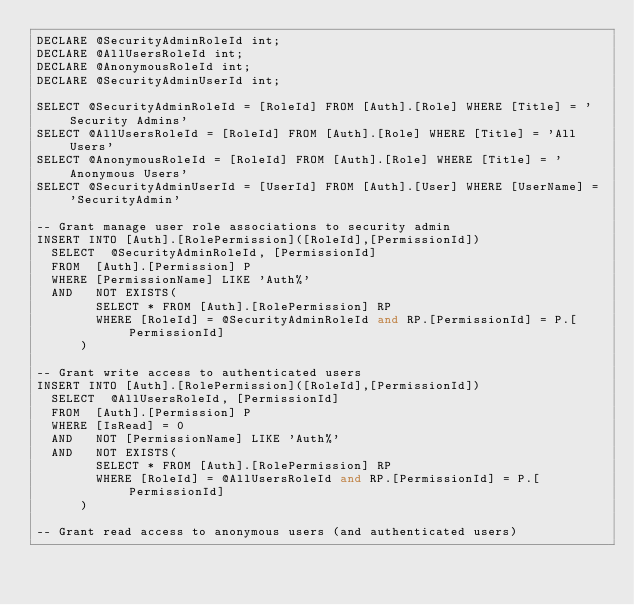Convert code to text. <code><loc_0><loc_0><loc_500><loc_500><_SQL_>DECLARE @SecurityAdminRoleId int;
DECLARE @AllUsersRoleId int;
DECLARE @AnonymousRoleId int;
DECLARE @SecurityAdminUserId int;

SELECT @SecurityAdminRoleId = [RoleId] FROM [Auth].[Role] WHERE [Title] = 'Security Admins'
SELECT @AllUsersRoleId = [RoleId] FROM [Auth].[Role] WHERE [Title] = 'All Users'
SELECT @AnonymousRoleId = [RoleId] FROM [Auth].[Role] WHERE [Title] = 'Anonymous Users'
SELECT @SecurityAdminUserId = [UserId] FROM [Auth].[User] WHERE [UserName] = 'SecurityAdmin'

-- Grant manage user role associations to security admin
INSERT INTO [Auth].[RolePermission]([RoleId],[PermissionId])
	SELECT	@SecurityAdminRoleId, [PermissionId]
	FROM	[Auth].[Permission] P
	WHERE	[PermissionName] LIKE 'Auth%'
	AND		NOT EXISTS(
				SELECT * FROM [Auth].[RolePermission] RP 
				WHERE [RoleId] = @SecurityAdminRoleId and RP.[PermissionId] = P.[PermissionId]
			)

-- Grant write access to authenticated users
INSERT INTO [Auth].[RolePermission]([RoleId],[PermissionId])
	SELECT	@AllUsersRoleId, [PermissionId]
	FROM	[Auth].[Permission] P
	WHERE	[IsRead] = 0
	AND		NOT [PermissionName] LIKE 'Auth%'
	AND		NOT EXISTS(
				SELECT * FROM [Auth].[RolePermission] RP 
				WHERE [RoleId] = @AllUsersRoleId and RP.[PermissionId] = P.[PermissionId]
			)

-- Grant read access to anonymous users (and authenticated users)</code> 